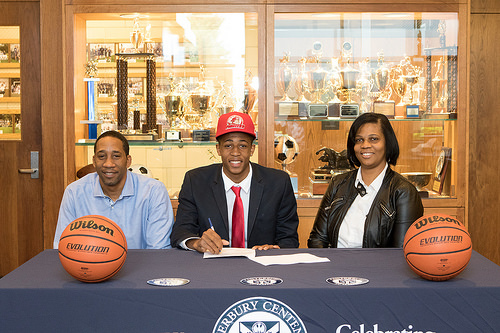<image>
Is the trophy on the boy? No. The trophy is not positioned on the boy. They may be near each other, but the trophy is not supported by or resting on top of the boy. 